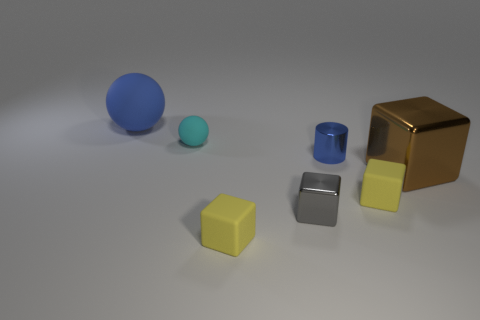What is the shape of the big object behind the cyan ball?
Your response must be concise. Sphere. There is a blue object that is the same material as the brown cube; what is its shape?
Keep it short and to the point. Cylinder. How many shiny things are either yellow things or cyan objects?
Ensure brevity in your answer.  0. What number of big things are behind the tiny rubber thing behind the large metallic block in front of the metallic cylinder?
Make the answer very short. 1. There is a gray cube that is in front of the tiny ball; is its size the same as the shiny thing to the right of the blue metal cylinder?
Your response must be concise. No. What is the material of the small gray object that is the same shape as the brown metallic object?
Your answer should be very brief. Metal. What number of small objects are either yellow rubber blocks or green shiny cylinders?
Provide a short and direct response. 2. What is the gray object made of?
Give a very brief answer. Metal. What material is the tiny object that is both on the left side of the gray block and in front of the tiny cyan thing?
Your answer should be compact. Rubber. Do the large cube and the tiny rubber thing that is on the right side of the small blue cylinder have the same color?
Your response must be concise. No. 